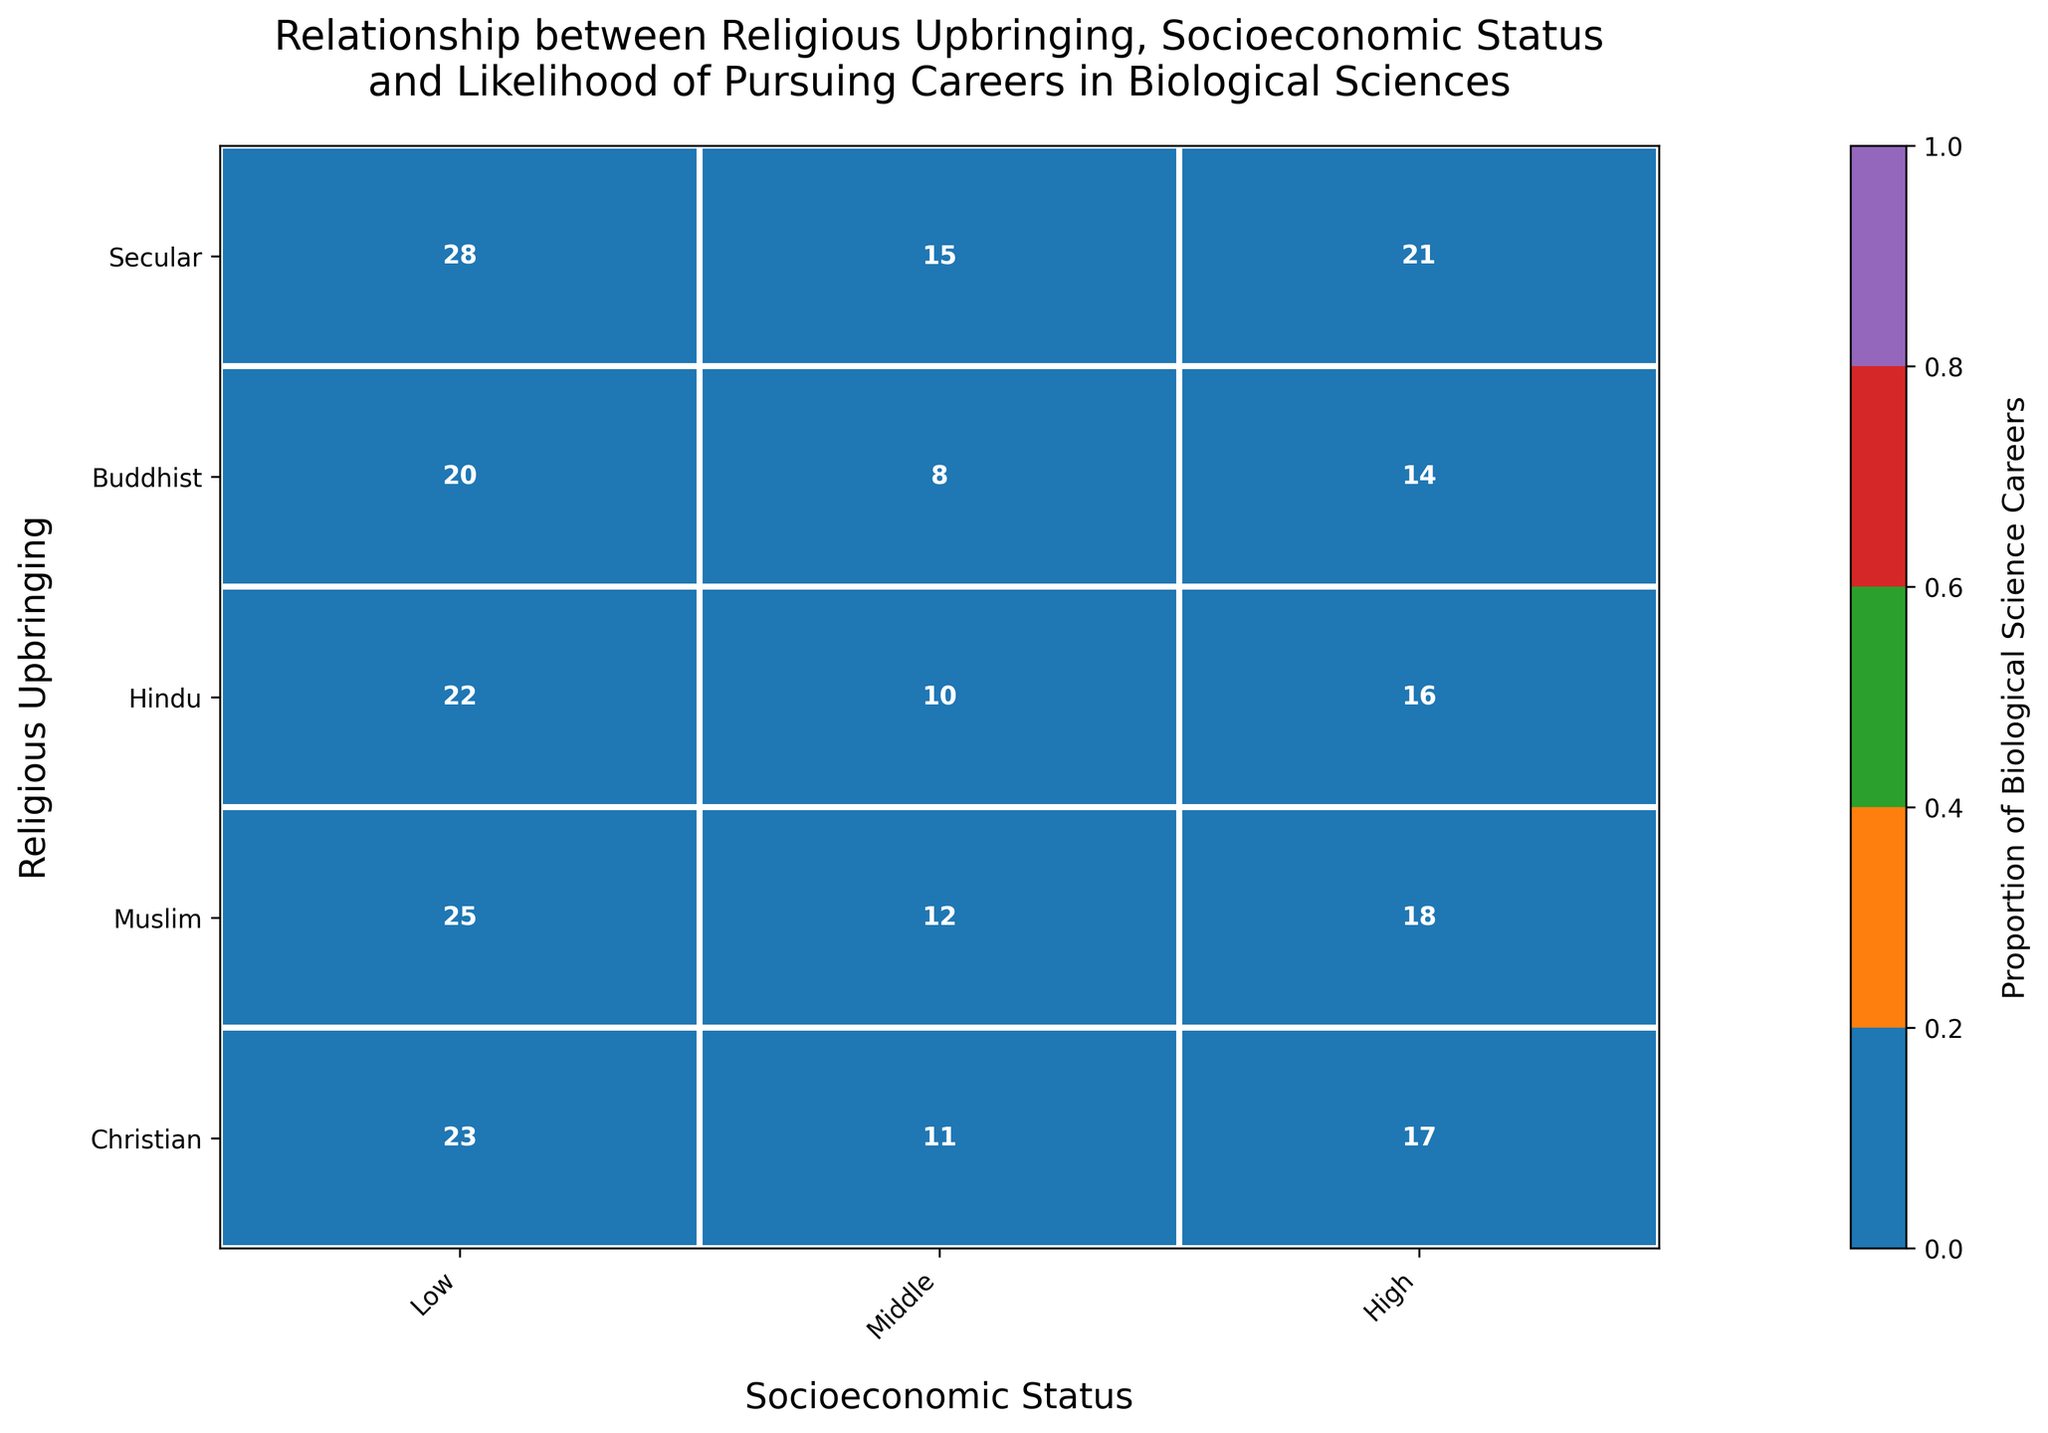What's the title of the displayed plot? From the figure, the title is usually placed at the top. By reading it, one can identify the main subject of the plot.
Answer: Relationship between Religious Upbringing, Socioeconomic Status and Likelihood of Pursuing Careers in Biological Sciences Which socioeconomic status shows the highest proportion of careers in biological sciences for the Buddhist upbringing? By observing the color intensities in the specific row for Buddhists, the darkest cell indicates the highest proportion.
Answer: High How many careers in biological sciences are observed for Christians with middle socioeconomic status? By locating the cell that corresponds to Christians and middle socioeconomic status, the number annotated in it can be identified.
Answer: 18 Is the proportion of biological science careers higher for Secular upbringing or Christian upbringing in the high socioeconomic category? Compare the color intensity in the 'High' column for both Secular and Christian upbringings. The darker hue represents a higher proportion.
Answer: Secular upbringing What is the sum of careers in biological sciences for the Muslim upbringing across all socioeconomic statuses? Add the numbers from all cells in the Muslim row. 8 (Low) + 14 (Middle) + 20 (High) = 42
Answer: 42 Which culture has the most balanced distribution across socioeconomic statuses for pursuing careers in biological sciences? Evaluate the spread of colors in each row. The most balanced distribution will show similar hues across all socioeconomic categories within that row.
Answer: Christian (Western) For the Hindu upbringing, what's the difference in the number of biological science careers between high and low socioeconomic statuses? Subtract the number of careers in the 'Low' socioeconomic status from those in the 'High' status for Hindus. 22 (High) - 10 (Low) = 12
Answer: 12 Does the plot suggest a higher overall tendency for religious or secular upbringing in pursuing biological science careers? Compare the overall color intensity of cells corresponding to religious groups (Christian, Muslim, Hindu, Buddhist) versus the Secular group across all socioeconomic statuses.
Answer: Secular upbringing Which religious upbringing shows the least variation in pursuing biological sciences across different socioeconomic statuses? Observe the color consistency across the row for each religious upbringing. The upbringing with the least variation in color intensity has the least variation.
Answer: Buddhist What can be inferred about the impact of socioeconomic status on the likelihood of pursuing a career in biological sciences for the Muslim upbringing? By evaluating the gradient of colors from low to high socioeconomic status for Muslims, one can see the upward trend in the hues indicating an increasing number of careers.
Answer: Higher socioeconomic status positively impacts the likelihood 